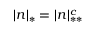Convert formula to latex. <formula><loc_0><loc_0><loc_500><loc_500>| n | _ { * } = | n | _ { * * } ^ { c }</formula> 